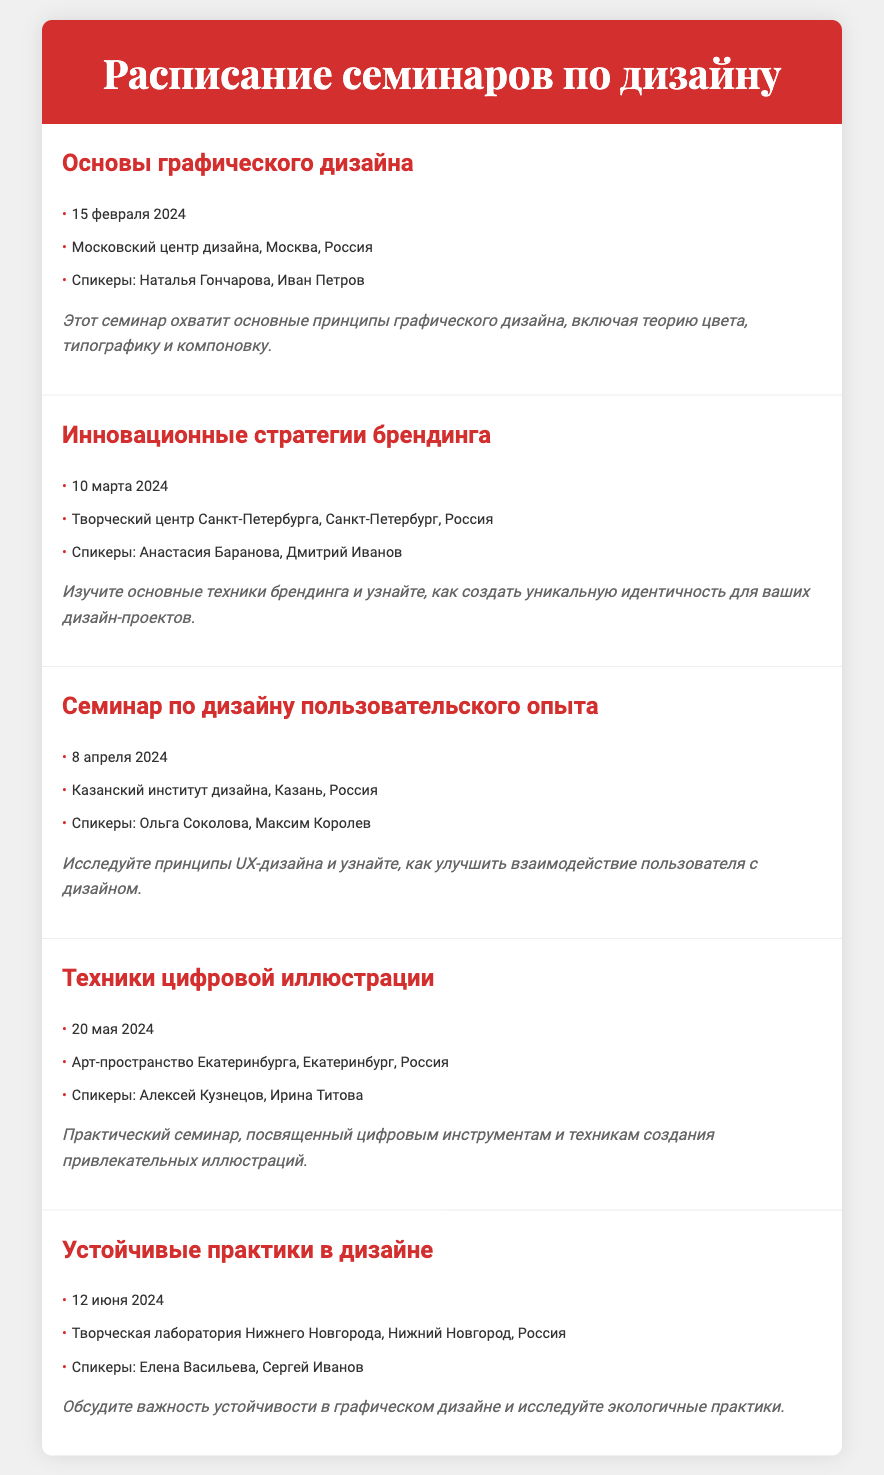Какое название семинара запланировано на 15 февраля 2024? Название семинара указано в документе под датой, это "Основы графического дизайна".
Answer: Основы графического дизайна Где пройдет семинар по устойчивым практикам в дизайне? Место проведения семинара указано под заголовком, это "Творческая лаборатория Нижнего Новгорода, Нижний Новгород, Россия".
Answer: Творческая лаборатория Нижнего Новгорода, Нижний Новгород, Россия Кто выступит на семинаре по дизайну пользовательского опыта? Спикеры указаны под названием семинара, это "Ольга Соколова, Максим Королев".
Answer: Ольга Соколова, Максим Королев Когда пройдет семинар по техникам цифровой иллюстрации? Дата семинара упоминается под названием, это "20 мая 2024".
Answer: 20 мая 2024 Какой семинар запланирован на 10 марта 2024? Семинар указан в документе с этой датой, это "Инновационные стратегии брендинга".
Answer: Инновационные стратегии брендинга Какова основная тема семинара о графическом дизайне? Это указано в описании семинара, охватывает "основные принципы графического дизайна, включая теорию цвета, типографику и компоновку".
Answer: основные принципы графического дизайна Какова дата семинара по устойчивым практикам в дизайне? Это указано непосредственно перед названием семинара, это "12 июня 2024".
Answer: 12 июня 2024 